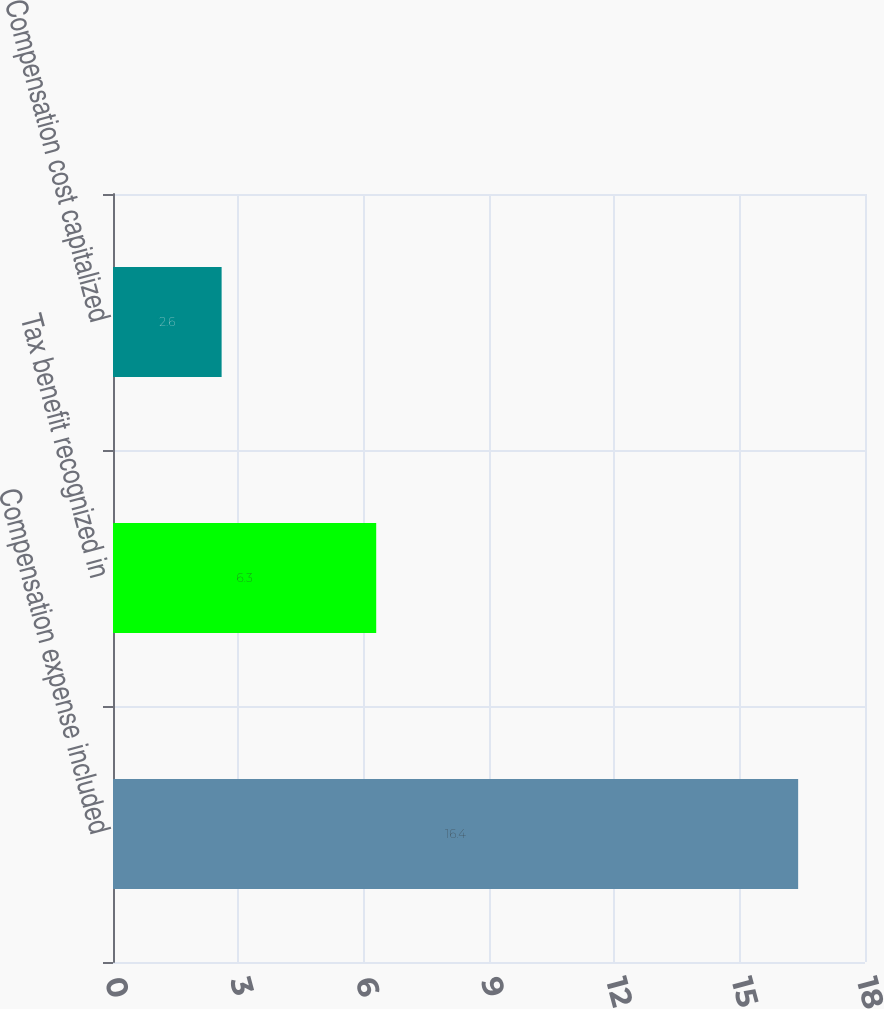<chart> <loc_0><loc_0><loc_500><loc_500><bar_chart><fcel>Compensation expense included<fcel>Tax benefit recognized in<fcel>Compensation cost capitalized<nl><fcel>16.4<fcel>6.3<fcel>2.6<nl></chart> 